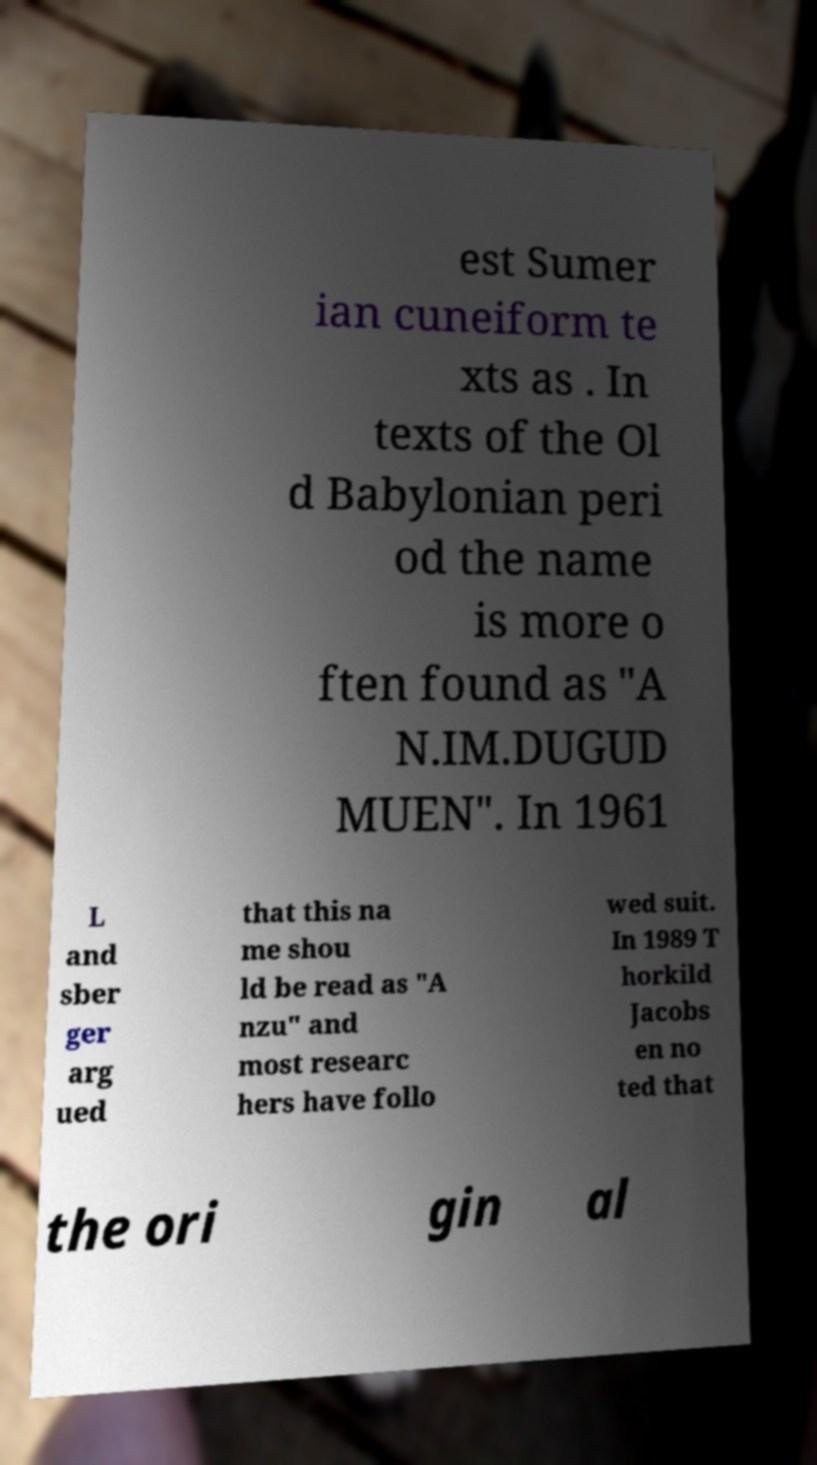Please identify and transcribe the text found in this image. est Sumer ian cuneiform te xts as . In texts of the Ol d Babylonian peri od the name is more o ften found as "A N.IM.DUGUD MUEN". In 1961 L and sber ger arg ued that this na me shou ld be read as "A nzu" and most researc hers have follo wed suit. In 1989 T horkild Jacobs en no ted that the ori gin al 